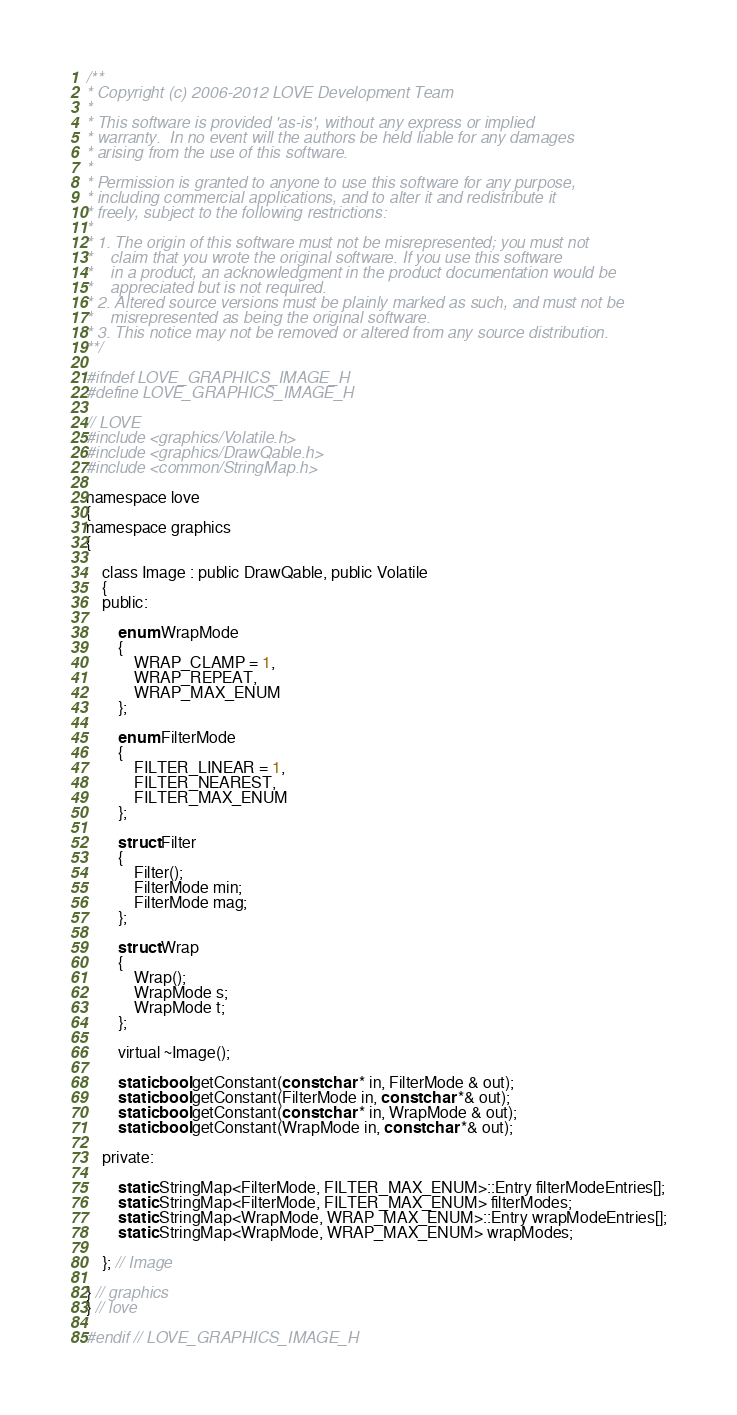Convert code to text. <code><loc_0><loc_0><loc_500><loc_500><_C_>/**
* Copyright (c) 2006-2012 LOVE Development Team
*
* This software is provided 'as-is', without any express or implied
* warranty.  In no event will the authors be held liable for any damages
* arising from the use of this software.
*
* Permission is granted to anyone to use this software for any purpose,
* including commercial applications, and to alter it and redistribute it
* freely, subject to the following restrictions:
*
* 1. The origin of this software must not be misrepresented; you must not
*    claim that you wrote the original software. If you use this software
*    in a product, an acknowledgment in the product documentation would be
*    appreciated but is not required.
* 2. Altered source versions must be plainly marked as such, and must not be
*    misrepresented as being the original software.
* 3. This notice may not be removed or altered from any source distribution.
**/

#ifndef LOVE_GRAPHICS_IMAGE_H
#define LOVE_GRAPHICS_IMAGE_H

// LOVE
#include <graphics/Volatile.h>
#include <graphics/DrawQable.h>
#include <common/StringMap.h>

namespace love
{
namespace graphics
{

	class Image : public DrawQable, public Volatile
	{
	public:

		enum WrapMode
		{
			WRAP_CLAMP = 1,
			WRAP_REPEAT,
			WRAP_MAX_ENUM
		};

		enum FilterMode
		{
			FILTER_LINEAR = 1,
			FILTER_NEAREST,
			FILTER_MAX_ENUM
		};

		struct Filter
		{
			Filter();
			FilterMode min;
			FilterMode mag;
		};

		struct Wrap
		{
			Wrap();
			WrapMode s;
			WrapMode t;
		};

		virtual ~Image();

		static bool getConstant(const char * in, FilterMode & out);
		static bool getConstant(FilterMode in, const char *& out);
		static bool getConstant(const char * in, WrapMode & out);
		static bool getConstant(WrapMode in, const char *& out);

	private:

		static StringMap<FilterMode, FILTER_MAX_ENUM>::Entry filterModeEntries[];
		static StringMap<FilterMode, FILTER_MAX_ENUM> filterModes;
		static StringMap<WrapMode, WRAP_MAX_ENUM>::Entry wrapModeEntries[];
		static StringMap<WrapMode, WRAP_MAX_ENUM> wrapModes;

	}; // Image

} // graphics
} // love

#endif // LOVE_GRAPHICS_IMAGE_H
</code> 